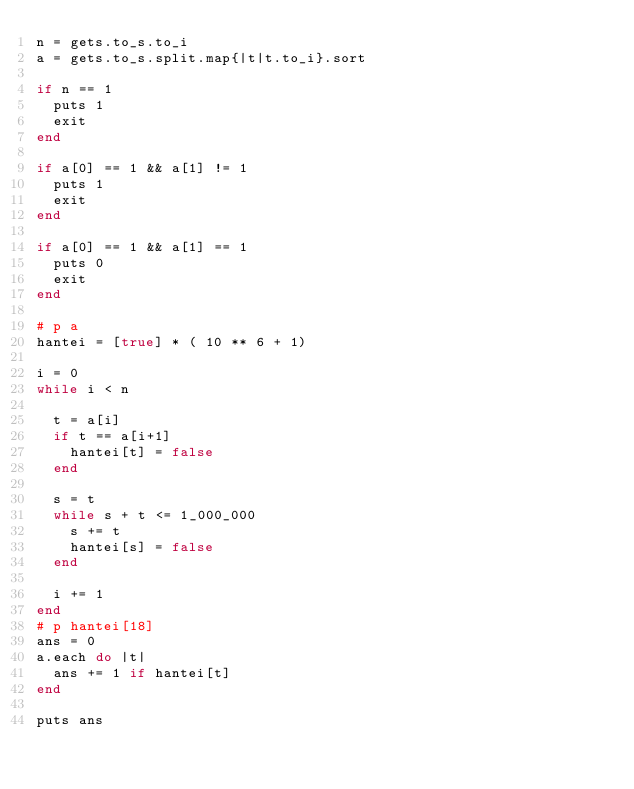<code> <loc_0><loc_0><loc_500><loc_500><_Ruby_>n = gets.to_s.to_i
a = gets.to_s.split.map{|t|t.to_i}.sort

if n == 1
  puts 1
  exit
end

if a[0] == 1 && a[1] != 1
  puts 1
  exit
end

if a[0] == 1 && a[1] == 1
  puts 0
  exit
end

# p a
hantei = [true] * ( 10 ** 6 + 1)

i = 0
while i < n
  
  t = a[i]
  if t == a[i+1]
    hantei[t] = false
  end
  
  s = t
  while s + t <= 1_000_000
    s += t
    hantei[s] = false
  end
  
  i += 1
end
# p hantei[18]
ans = 0
a.each do |t|
  ans += 1 if hantei[t]
end

puts ans</code> 